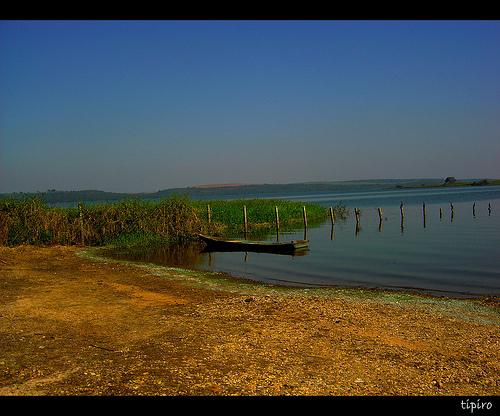Can you list two visible land elements in the image? Rocky shore and area of dirt and moss What type of task would be suitable for determining the number of posts in the water? Object counting task Can you describe the weather in the scene? The weather appears to be clear, with a clear blue sky and no clouds in sight. Analyze the sentiment of the image based on the elements present. The sentiment of the image is calm and serene, due to the large calm body of water, clear blue sky, and the peaceful surroundings. What is the most prominent natural element present in the image? The most prominent natural element is the large blue lake. What type of task should be used to describe the interaction between the boat and its environment? Object interaction analysis task Can you provide a brief description of the image? The image features a calm, large blue lake with a small green boat in the water, surrounded by shrubs and a rocky shore. Wooden posts and tree stumps stick out of the water, and clear blue sky with no clouds is visible in the background. Describe the area where the boat is located. The boat is located in the calm water near the shore, surrounded by wooden posts sticking out of the water and a reflection of shrubs in the water. How many boats are there in the image and what are their characteristics? There is one boat in the image, which is small, green, and empty, located in the calm body of water near the shoreline. What is the state of the water in the lake and its surrounding landscape? The water in the lake is calm with thin ripples, and there is a reflection of shrubs in it. The surrounding landscape includes green grass, rocky shore, dirt and moss, and shrubs growing by the lake. 